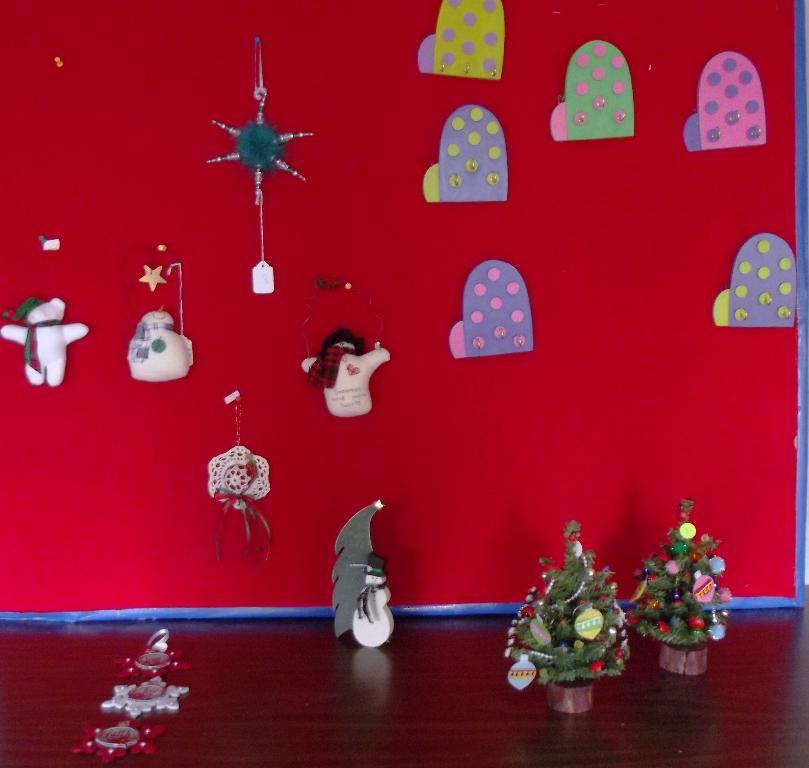What is the main object in the image? There is a board in the image. What type of keychains are on the board? There are snowman keychains on the board. Are there any other items on the board besides the keychains? Yes, there are other items placed on the board. What can be seen on the table in the image? There are Christmas trees on a table in the image. What type of star can be seen in the sky in the image? There is no sky visible in the image, so it is not possible to determine if there is a star present. 